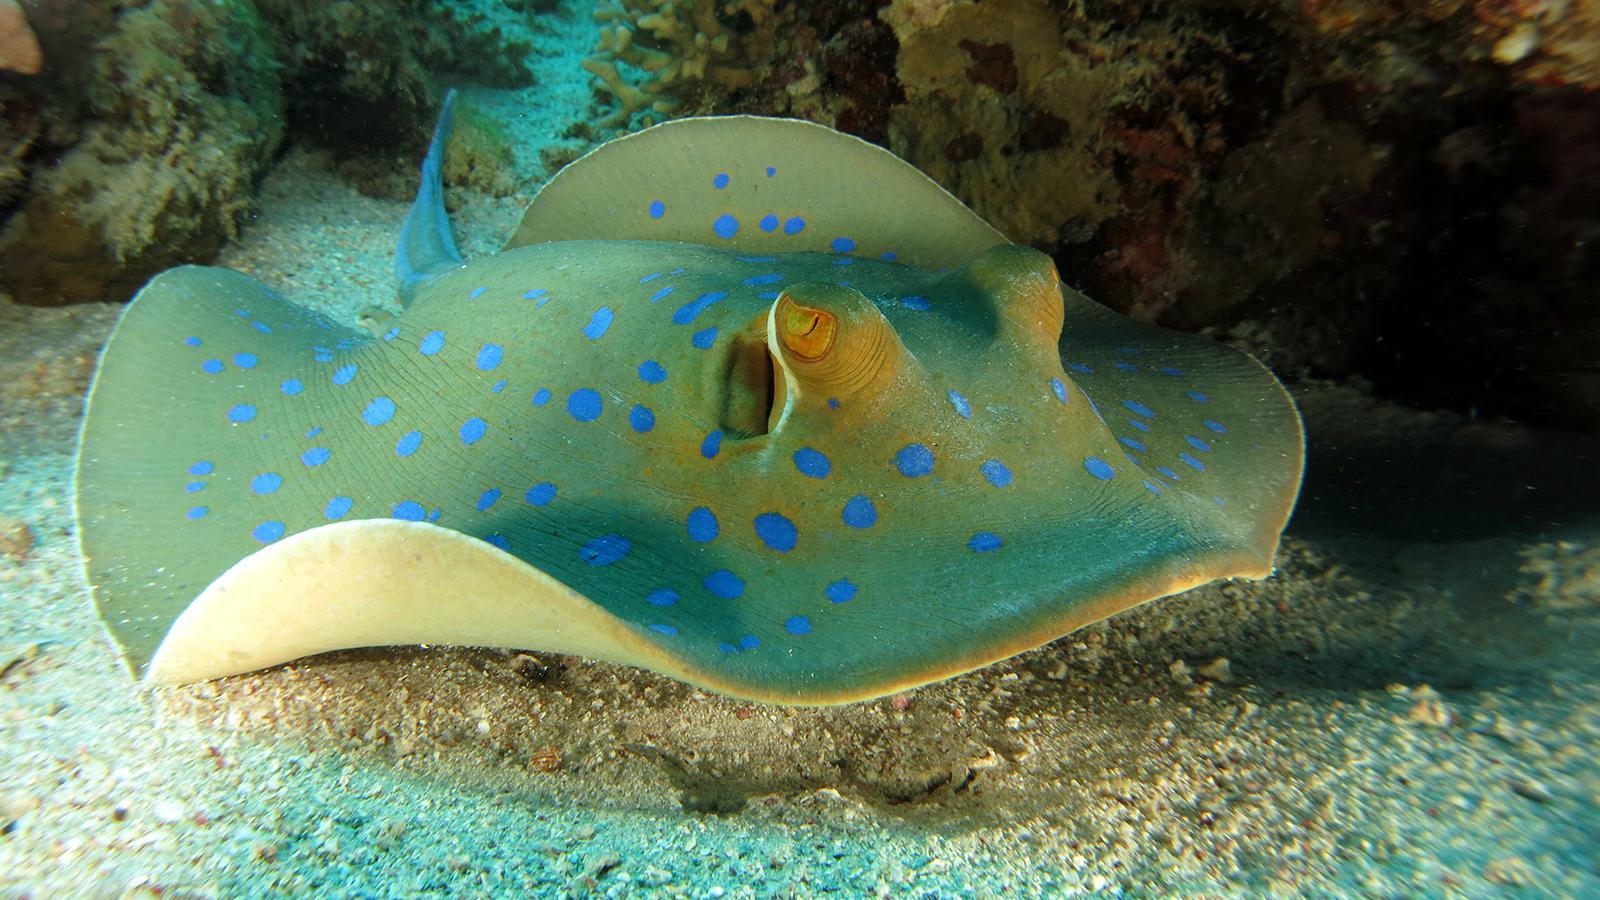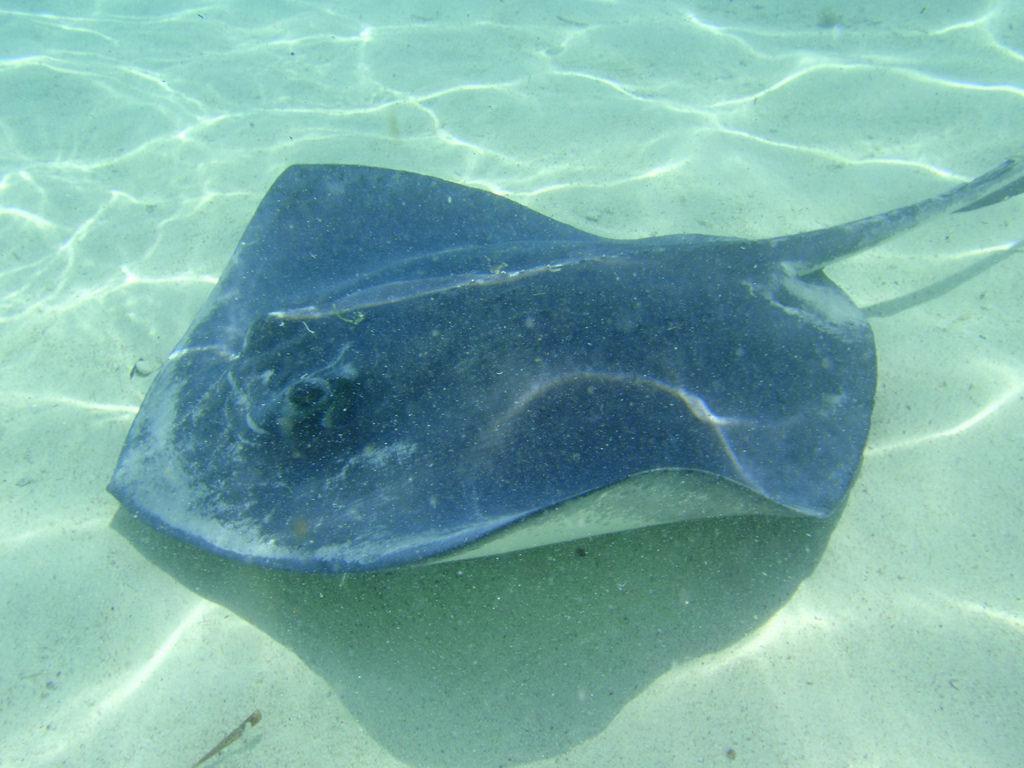The first image is the image on the left, the second image is the image on the right. Examine the images to the left and right. Is the description "A total of two stingrays are shown swimming in vivid blue water, with undersides visible." accurate? Answer yes or no. No. 